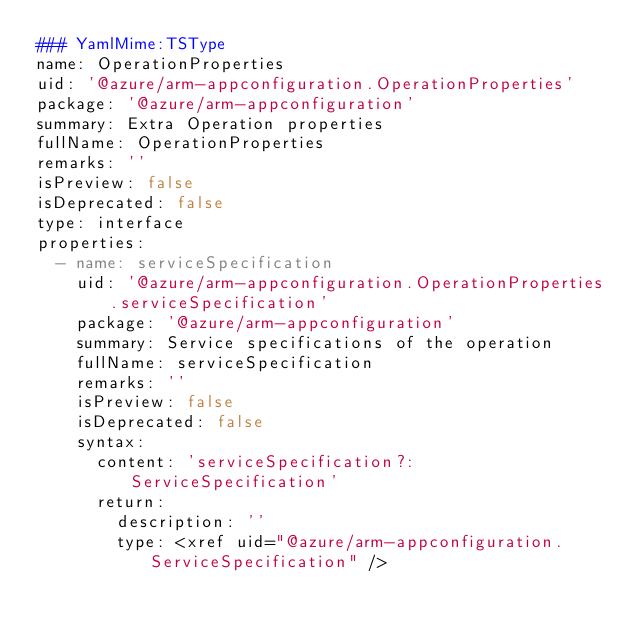<code> <loc_0><loc_0><loc_500><loc_500><_YAML_>### YamlMime:TSType
name: OperationProperties
uid: '@azure/arm-appconfiguration.OperationProperties'
package: '@azure/arm-appconfiguration'
summary: Extra Operation properties
fullName: OperationProperties
remarks: ''
isPreview: false
isDeprecated: false
type: interface
properties:
  - name: serviceSpecification
    uid: '@azure/arm-appconfiguration.OperationProperties.serviceSpecification'
    package: '@azure/arm-appconfiguration'
    summary: Service specifications of the operation
    fullName: serviceSpecification
    remarks: ''
    isPreview: false
    isDeprecated: false
    syntax:
      content: 'serviceSpecification?: ServiceSpecification'
      return:
        description: ''
        type: <xref uid="@azure/arm-appconfiguration.ServiceSpecification" />
</code> 